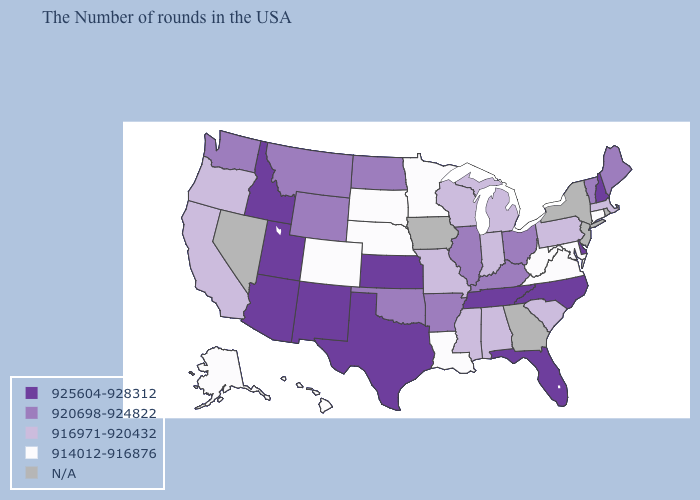What is the value of Colorado?
Concise answer only. 914012-916876. What is the value of Tennessee?
Quick response, please. 925604-928312. Name the states that have a value in the range N/A?
Write a very short answer. Rhode Island, New York, New Jersey, Georgia, Iowa, Nevada. Is the legend a continuous bar?
Write a very short answer. No. Name the states that have a value in the range N/A?
Answer briefly. Rhode Island, New York, New Jersey, Georgia, Iowa, Nevada. Name the states that have a value in the range 916971-920432?
Short answer required. Massachusetts, Pennsylvania, South Carolina, Michigan, Indiana, Alabama, Wisconsin, Mississippi, Missouri, California, Oregon. Among the states that border Kansas , which have the highest value?
Keep it brief. Oklahoma. What is the value of Georgia?
Be succinct. N/A. What is the value of Missouri?
Write a very short answer. 916971-920432. Which states have the lowest value in the Northeast?
Write a very short answer. Connecticut. What is the value of Washington?
Give a very brief answer. 920698-924822. 